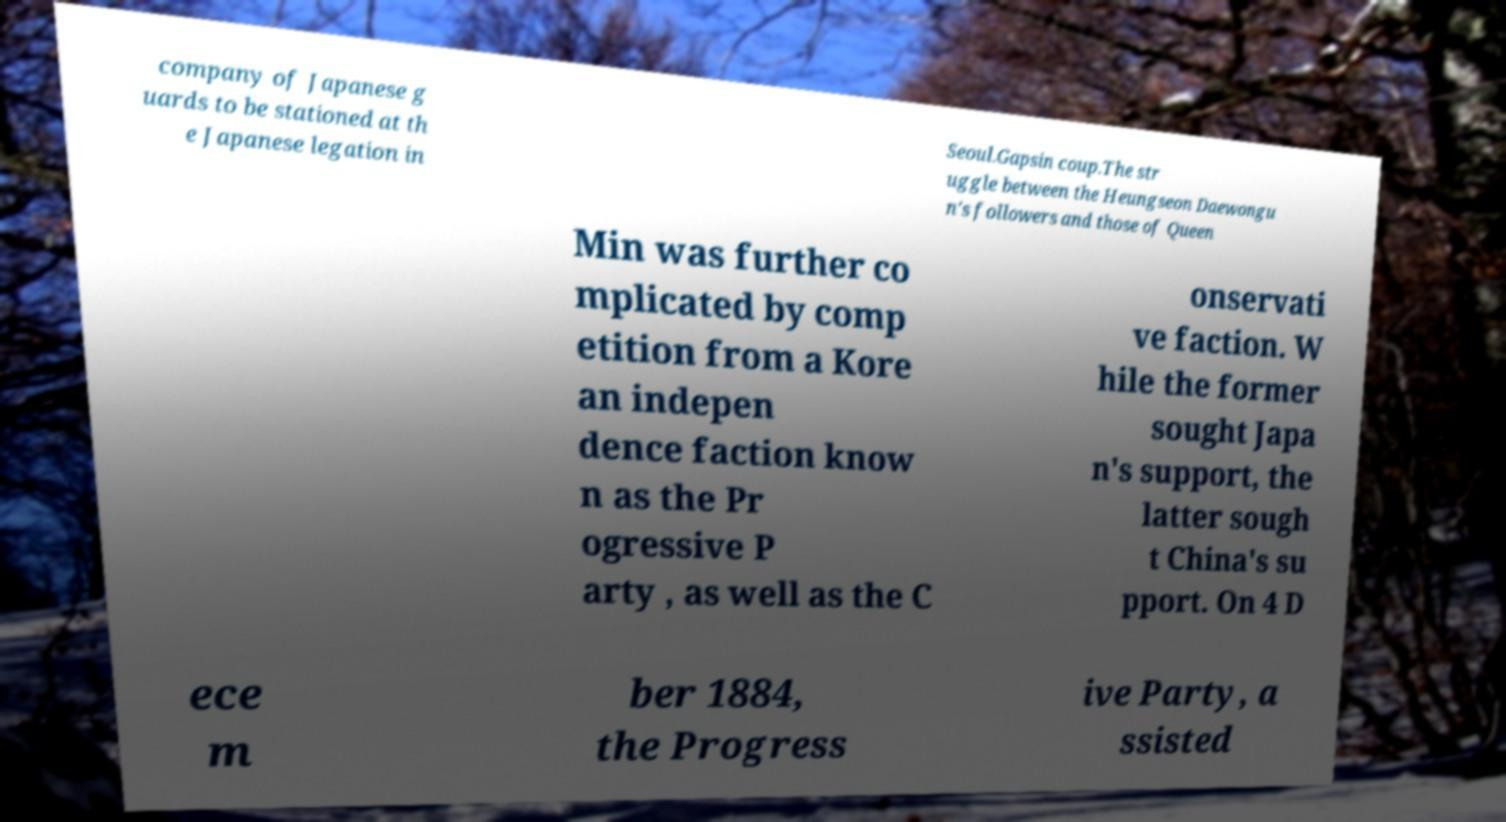Please read and relay the text visible in this image. What does it say? company of Japanese g uards to be stationed at th e Japanese legation in Seoul.Gapsin coup.The str uggle between the Heungseon Daewongu n's followers and those of Queen Min was further co mplicated by comp etition from a Kore an indepen dence faction know n as the Pr ogressive P arty , as well as the C onservati ve faction. W hile the former sought Japa n's support, the latter sough t China's su pport. On 4 D ece m ber 1884, the Progress ive Party, a ssisted 